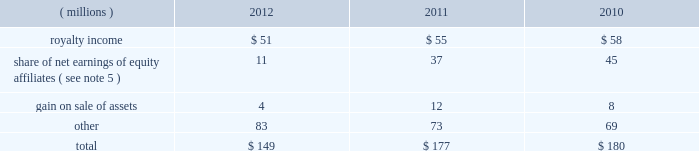68 2012 ppg annual report and form 10-k december 31 , 2012 , 2011 and 2010 was $ ( 30 ) million , $ 98 million and $ 65 million , respectively .
The cumulative tax benefit related to the adjustment for pension and other postretirement benefits at december 31 , 2012 and 2011 was approximately $ 960 million and $ 990 million , respectively .
There was no tax ( cost ) benefit related to the change in the unrealized gain ( loss ) on marketable securities for the year ended december 31 , 2012 .
The tax ( cost ) benefit related to the change in the unrealized gain ( loss ) on marketable securities for the years ended december 31 , 2011 and 2010 was $ ( 0.2 ) million and $ 0.6 million , respectively .
The tax benefit related to the change in the unrealized gain ( loss ) on derivatives for the years ended december 31 , 2012 , 2011 and 2010 was $ 4 million , $ 19 million and $ 1 million , respectively .
18 .
Employee savings plan ppg 2019s employee savings plan ( 201csavings plan 201d ) covers substantially all u.s .
Employees .
The company makes matching contributions to the savings plan , at management's discretion , based upon participants 2019 savings , subject to certain limitations .
For most participants not covered by a collective bargaining agreement , company-matching contributions are established each year at the discretion of the company and are applied to participant savings up to a maximum of 6% ( 6 % ) of eligible participant compensation .
For those participants whose employment is covered by a collective bargaining agreement , the level of company-matching contribution , if any , is determined by the relevant collective bargaining agreement .
The company-matching contribution was suspended from march 2009 through june 2010 as a cost savings measure in recognition of the adverse impact of the global recession .
Effective july 1 , 2010 , the company match was reinstated at 50% ( 50 % ) on the first 6% ( 6 % ) of compensation contributed for most employees eligible for the company-matching contribution feature .
This included the union represented employees in accordance with their collective bargaining agreements .
On january 1 , 2011 , the company match was increased to 75% ( 75 % ) on the first 6% ( 6 % ) of compensation contributed by these eligible employees and this level was maintained throughout 2012 .
Compensation expense and cash contributions related to the company match of participant contributions to the savings plan for 2012 , 2011 and 2010 totaled $ 28 million , $ 26 million and $ 9 million , respectively .
A portion of the savings plan qualifies under the internal revenue code as an employee stock ownership plan .
As a result , the dividends on ppg shares held by that portion of the savings plan totaling $ 18 million , $ 20 million and $ 24 million for 2012 , 2011 and 2010 , respectively , were tax deductible to the company for u.s .
Federal tax purposes .
19 .
Other earnings .
20 .
Stock-based compensation the company 2019s stock-based compensation includes stock options , restricted stock units ( 201crsus 201d ) and grants of contingent shares that are earned based on achieving targeted levels of total shareholder return .
All current grants of stock options , rsus and contingent shares are made under the ppg industries , inc .
Amended and restated omnibus incentive plan ( 201cppg amended omnibus plan 201d ) , which was amended and restated effective april 21 , 2011 .
Shares available for future grants under the ppg amended omnibus plan were 8.5 million as of december 31 , 2012 .
Total stock-based compensation cost was $ 73 million , $ 36 million and $ 52 million in 2012 , 2011 and 2010 , respectively .
Stock-based compensation expense increased year over year due to the increase in the expected payout percentage of the 2010 performance-based rsu grants and ppg's total shareholder return performance in 2012 in comparison with the standard & poors ( s&p ) 500 index , which has increased the expense related to outstanding grants of contingent shares .
The total income tax benefit recognized in the accompanying consolidated statement of income related to the stock-based compensation was $ 25 million , $ 13 million and $ 18 million in 2012 , 2011 and 2010 , respectively .
Stock options ppg has outstanding stock option awards that have been granted under two stock option plans : the ppg industries , inc .
Stock plan ( 201cppg stock plan 201d ) and the ppg amended omnibus plan .
Under the ppg amended omnibus plan and the ppg stock plan , certain employees of the company have been granted options to purchase shares of common stock at prices equal to the fair market value of the shares on the date the options were granted .
The options are generally exercisable beginning from six to 48 months after being granted and have a maximum term of 10 years .
Upon exercise of a stock option , shares of company stock are issued from treasury stock .
The ppg stock plan includes a restored option provision for options originally granted prior to january 1 , 2003 that allows an optionee to exercise options and satisfy the option cost by certifying ownership of mature shares of ppg common stock with a market value equal to the option cost .
The fair value of stock options issued to employees is measured on the date of grant and is recognized as expense over the requisite service period .
Ppg estimates the fair value of stock options using the black-scholes option pricing model .
The risk- free interest rate is determined by using the u.s .
Treasury yield table of contents .
In millions , what would 2012 other income have been without the benefit of royalty income? 
Computations: (149 - 51)
Answer: 98.0. 